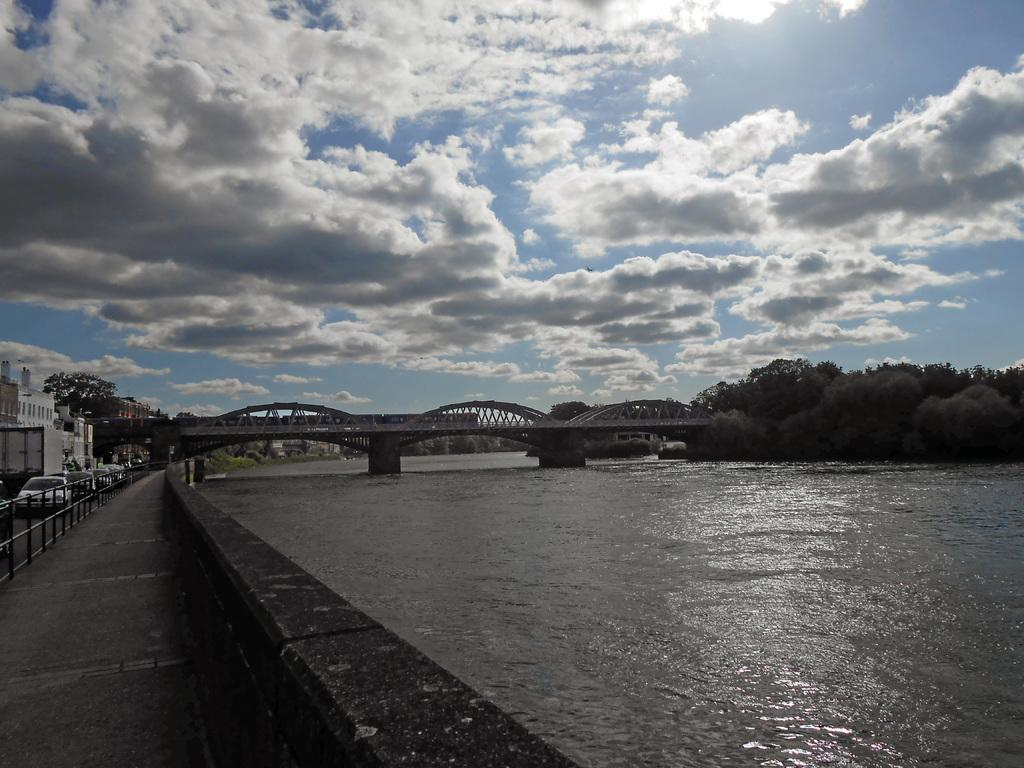What type of structure can be seen in the image? There is a wall in the image. What can be found near the wall? There is a footpath in the image. What is visible in the image that is related to water? Water is visible in the image. What type of barrier is present in the image? There is a fence in the image. What type of transportation can be seen in the image? There are vehicles on the road in the image. What type of structure is present for crossing water? There is a bridge in the image. What type of man-made structures are present in the image? There are buildings in the image. What type of natural vegetation is present in the image? There are trees in the image. What can be seen in the background of the image? The sky is visible in the background of the image. What type of weather can be inferred from the image? There are clouds in the sky, suggesting a partly cloudy day. What type of wrist accessory is visible on the person in the image? There are no people visible in the image, so it is impossible to determine if there is a wrist accessory present. What type of notebook is being used by the person in the image? There are no people visible in the image, so it is impossible to determine if there is a notebook present. 